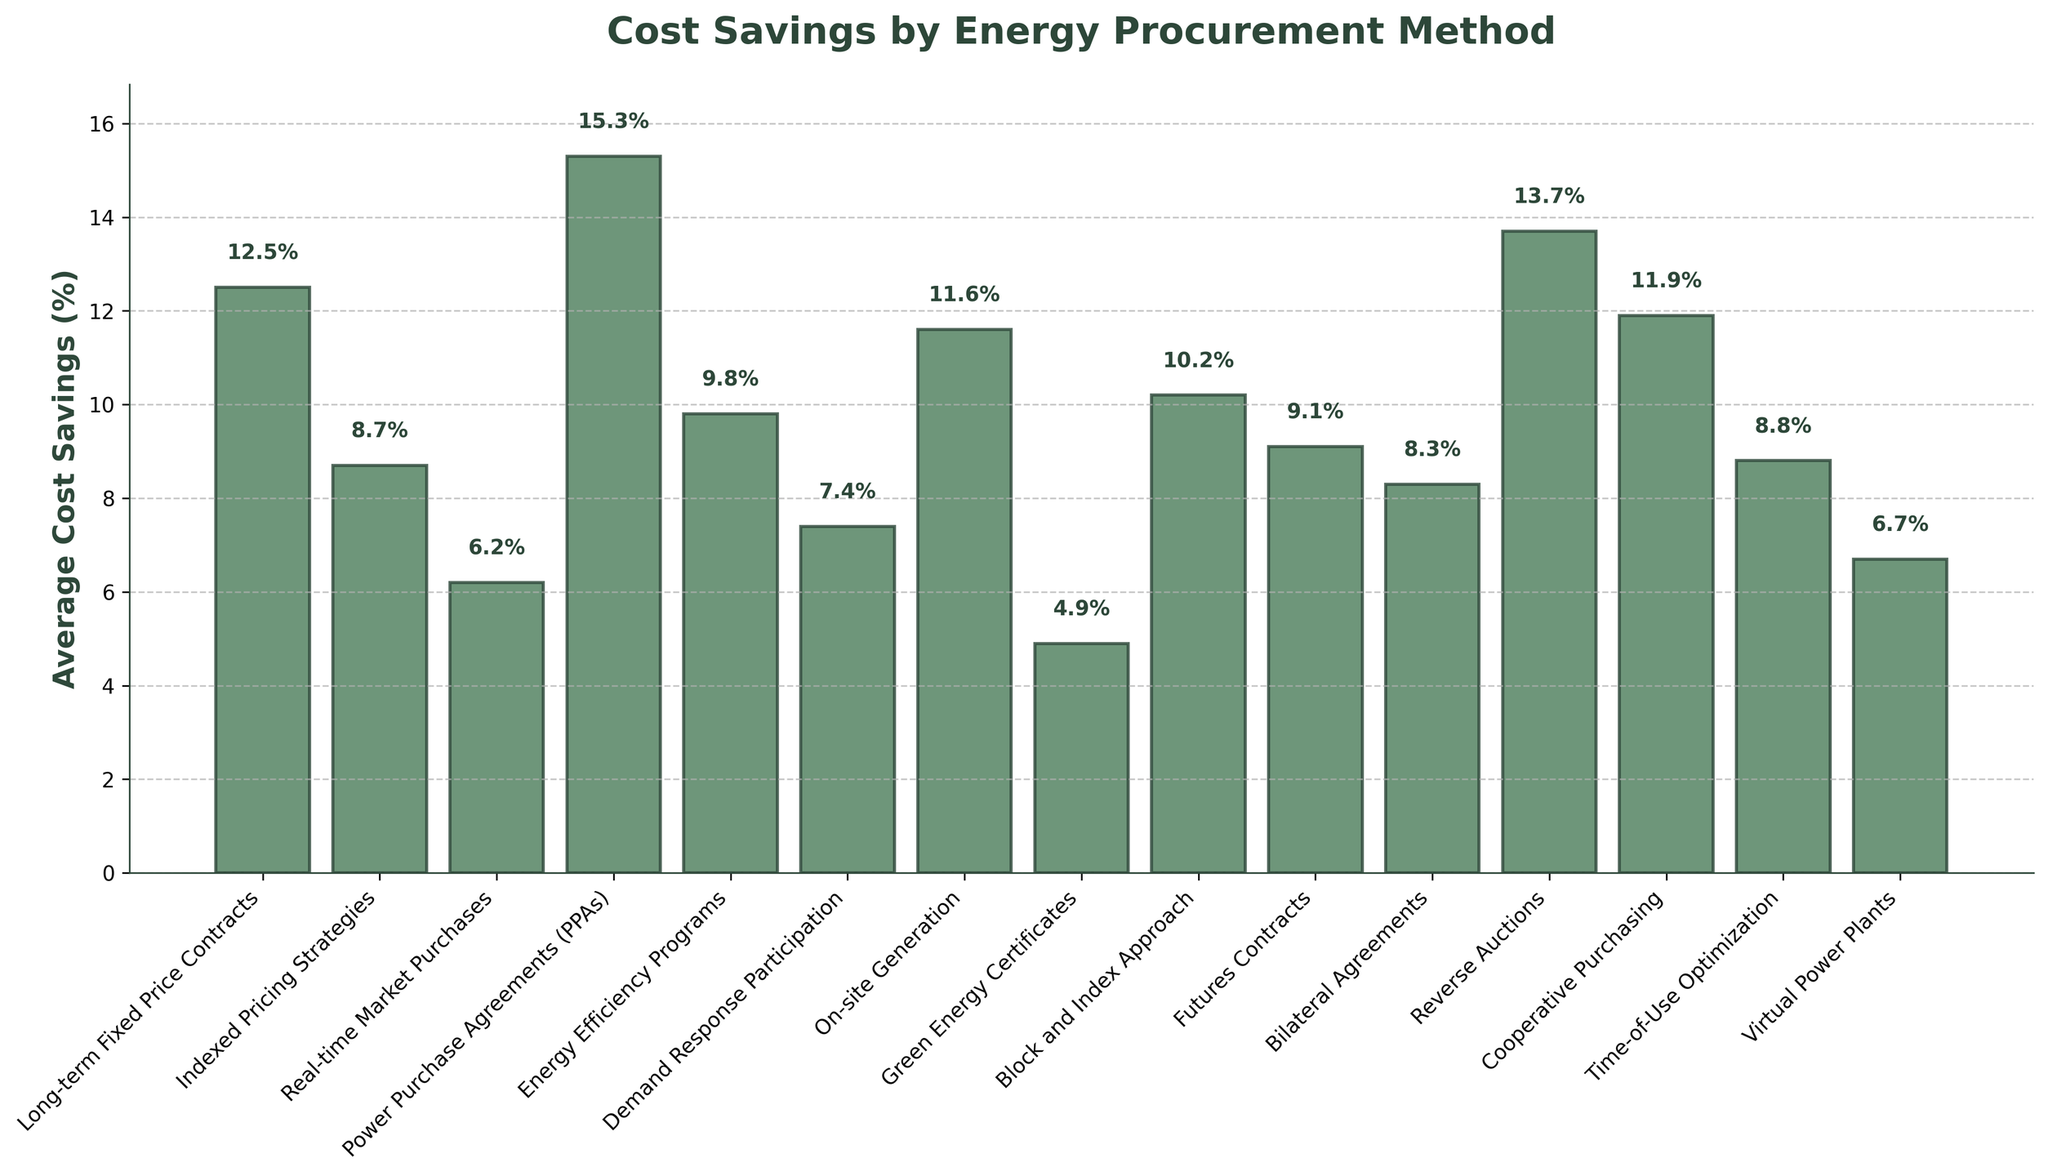Which procurement method yields the highest average cost savings? By examining the bar heights, "Power Purchase Agreements (PPAs)" has the tallest bar, indicating the highest average cost savings at 15.3%.
Answer: Power Purchase Agreements (PPAs) Which procurement method has the lowest average cost savings? The shortest bar in the plot corresponds to "Green Energy Certificates" with an average cost savings of 4.9%.
Answer: Green Energy Certificates What is the difference in average cost savings between the highest and the lowest procurement methods? Subtract the lowest cost savings (4.9% for Green Energy Certificates) from the highest cost savings (15.3% for PPAs): 15.3% - 4.9% = 10.4%.
Answer: 10.4% How does the average cost savings of "Reverse Auctions" compare to "Long-term Fixed Price Contracts"? The height of the bar for "Reverse Auctions" (13.7%) is higher than that of "Long-term Fixed Price Contracts" (12.5%), indicating greater cost savings.
Answer: Reverse Auctions have higher cost savings than Long-term Fixed Price Contracts Which procurement methods have an average cost savings greater than 10%? By analyzing the bars taller than the 10% mark, the methods are "Long-term Fixed Price Contracts" (12.5%), "Power Purchase Agreements (PPAs)" (15.3%), "Reverse Auctions" (13.7%), "On-site Generation" (11.6%), "Block and Index Approach" (10.2%), and "Cooperative Purchasing" (11.9%).
Answer: Long-term Fixed Price Contracts, PPAs, Reverse Auctions, On-site Generation, Block and Index Approach, Cooperative Purchasing What is the total average cost savings for "Demand Response Participation" and "Virtual Power Plants"? Add the cost savings of both methods together: 7.4% (Demand Response Participation) + 6.7% (Virtual Power Plants) = 14.1%.
Answer: 14.1% Which two methods have the closest average cost savings values, and what are those values? "Indexed Pricing Strategies" (8.7%) and "Time-of-Use Optimization" (8.8%) have the closest values, with only a 0.1% difference between them.
Answer: Indexed Pricing Strategies (8.7%) and Time-of-Use Optimization (8.8%) What is the average cost savings of the top three procurement methods? Sum the cost savings of the top three methods and divide by three: (15.3% for PPAs + 13.7% for Reverse Auctions + 12.5% for Long-term Fixed Price Contracts) / 3 = 41.5% / 3 = 13.83%.
Answer: 13.83% Which procurement method has a higher average cost savings: "Energy Efficiency Programs" or "On-site Generation"? Comparing the heights of the bars, "On-site Generation" has a higher average cost savings (11.6%) compared to "Energy Efficiency Programs" (9.8%).
Answer: On-site Generation What is the median average cost savings among all listed procurement methods? List the values in ascending order: 4.9%, 6.2%, 6.7%, 7.4%, 8.3%, 8.7%, 8.8%, 9.1%, 9.8%, 10.2%, 11.6%, 11.9%, 12.5%, 13.7%, 15.3%. The middle value is the 8th one: 9.1% (Futures Contracts).
Answer: 9.1% 